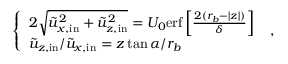<formula> <loc_0><loc_0><loc_500><loc_500>\left \{ \begin{array} { l l } { 2 \sqrt { \tilde { u } _ { x , i n } ^ { 2 } + \tilde { u } _ { z , i n } ^ { 2 } } = U _ { 0 } e r f \left [ \frac { 2 ( r _ { b } - | z | ) } { \delta } \right ] } \\ { \tilde { u } _ { z , i n } / \tilde { u } _ { x , i n } = z \tan { \alpha } / r _ { b } } \end{array} \ ,</formula> 